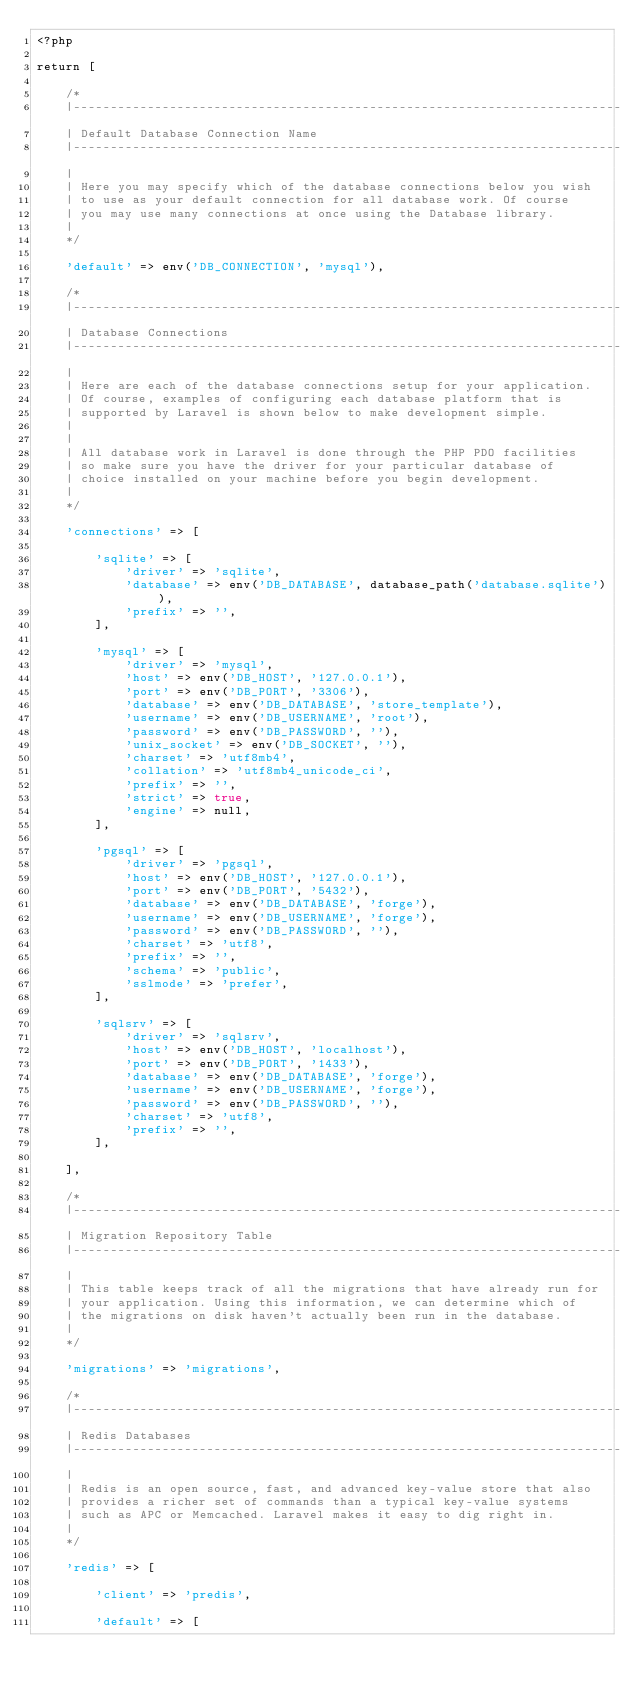Convert code to text. <code><loc_0><loc_0><loc_500><loc_500><_PHP_><?php

return [

    /*
    |--------------------------------------------------------------------------
    | Default Database Connection Name
    |--------------------------------------------------------------------------
    |
    | Here you may specify which of the database connections below you wish
    | to use as your default connection for all database work. Of course
    | you may use many connections at once using the Database library.
    |
    */

    'default' => env('DB_CONNECTION', 'mysql'),

    /*
    |--------------------------------------------------------------------------
    | Database Connections
    |--------------------------------------------------------------------------
    |
    | Here are each of the database connections setup for your application.
    | Of course, examples of configuring each database platform that is
    | supported by Laravel is shown below to make development simple.
    |
    |
    | All database work in Laravel is done through the PHP PDO facilities
    | so make sure you have the driver for your particular database of
    | choice installed on your machine before you begin development.
    |
    */

    'connections' => [

        'sqlite' => [
            'driver' => 'sqlite',
            'database' => env('DB_DATABASE', database_path('database.sqlite')),
            'prefix' => '',
        ],

        'mysql' => [
            'driver' => 'mysql',
            'host' => env('DB_HOST', '127.0.0.1'),
            'port' => env('DB_PORT', '3306'),
            'database' => env('DB_DATABASE', 'store_template'),
            'username' => env('DB_USERNAME', 'root'),
            'password' => env('DB_PASSWORD', ''),
            'unix_socket' => env('DB_SOCKET', ''),
            'charset' => 'utf8mb4',
            'collation' => 'utf8mb4_unicode_ci',
            'prefix' => '',
            'strict' => true,
            'engine' => null,
        ],

        'pgsql' => [
            'driver' => 'pgsql',
            'host' => env('DB_HOST', '127.0.0.1'),
            'port' => env('DB_PORT', '5432'),
            'database' => env('DB_DATABASE', 'forge'),
            'username' => env('DB_USERNAME', 'forge'),
            'password' => env('DB_PASSWORD', ''),
            'charset' => 'utf8',
            'prefix' => '',
            'schema' => 'public',
            'sslmode' => 'prefer',
        ],

        'sqlsrv' => [
            'driver' => 'sqlsrv',
            'host' => env('DB_HOST', 'localhost'),
            'port' => env('DB_PORT', '1433'),
            'database' => env('DB_DATABASE', 'forge'),
            'username' => env('DB_USERNAME', 'forge'),
            'password' => env('DB_PASSWORD', ''),
            'charset' => 'utf8',
            'prefix' => '',
        ],

    ],

    /*
    |--------------------------------------------------------------------------
    | Migration Repository Table
    |--------------------------------------------------------------------------
    |
    | This table keeps track of all the migrations that have already run for
    | your application. Using this information, we can determine which of
    | the migrations on disk haven't actually been run in the database.
    |
    */

    'migrations' => 'migrations',

    /*
    |--------------------------------------------------------------------------
    | Redis Databases
    |--------------------------------------------------------------------------
    |
    | Redis is an open source, fast, and advanced key-value store that also
    | provides a richer set of commands than a typical key-value systems
    | such as APC or Memcached. Laravel makes it easy to dig right in.
    |
    */

    'redis' => [

        'client' => 'predis',

        'default' => [</code> 